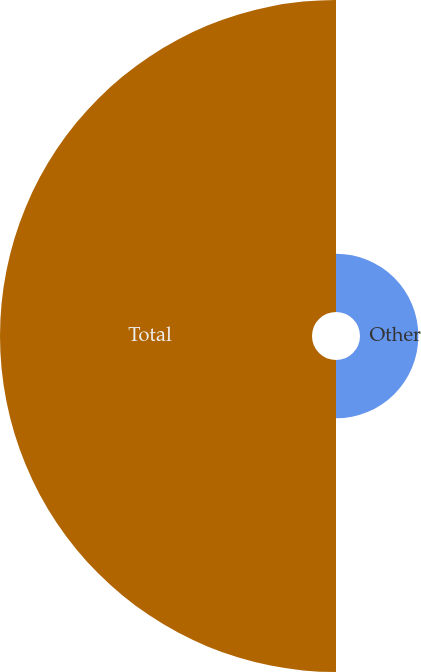Convert chart to OTSL. <chart><loc_0><loc_0><loc_500><loc_500><pie_chart><fcel>Other<fcel>Total<nl><fcel>15.76%<fcel>84.24%<nl></chart> 